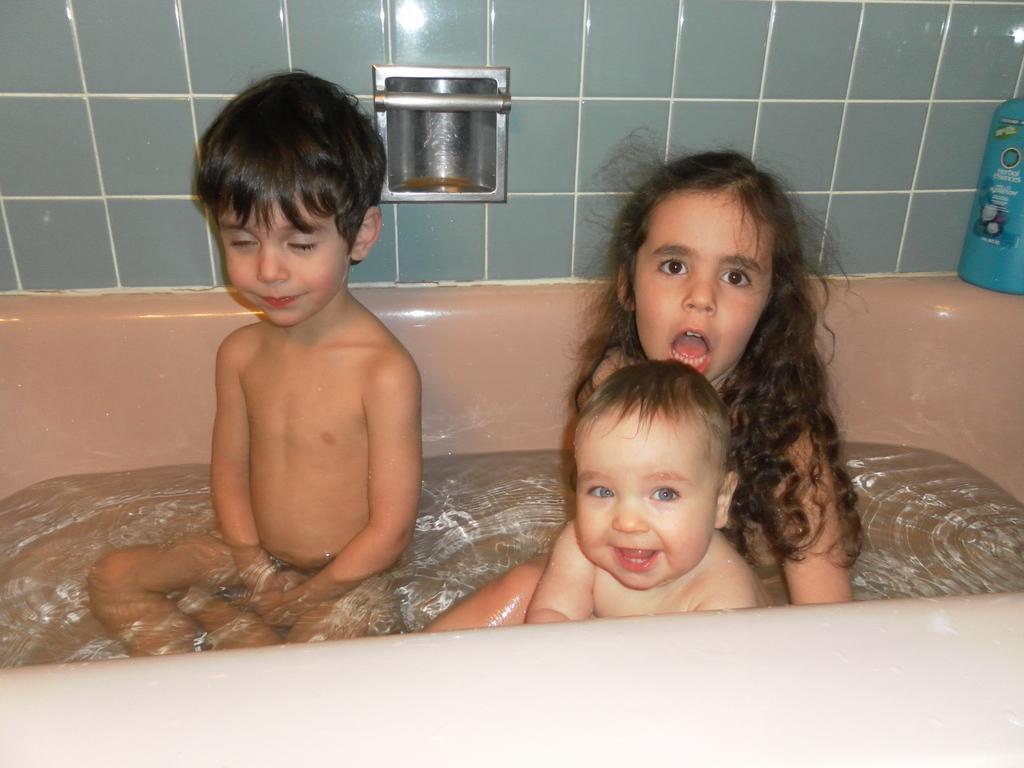Please provide a concise description of this image. In this image we can see children in the bathtub. In the background of the image there is wall. To the right side of the image there is a blue color bottle. 